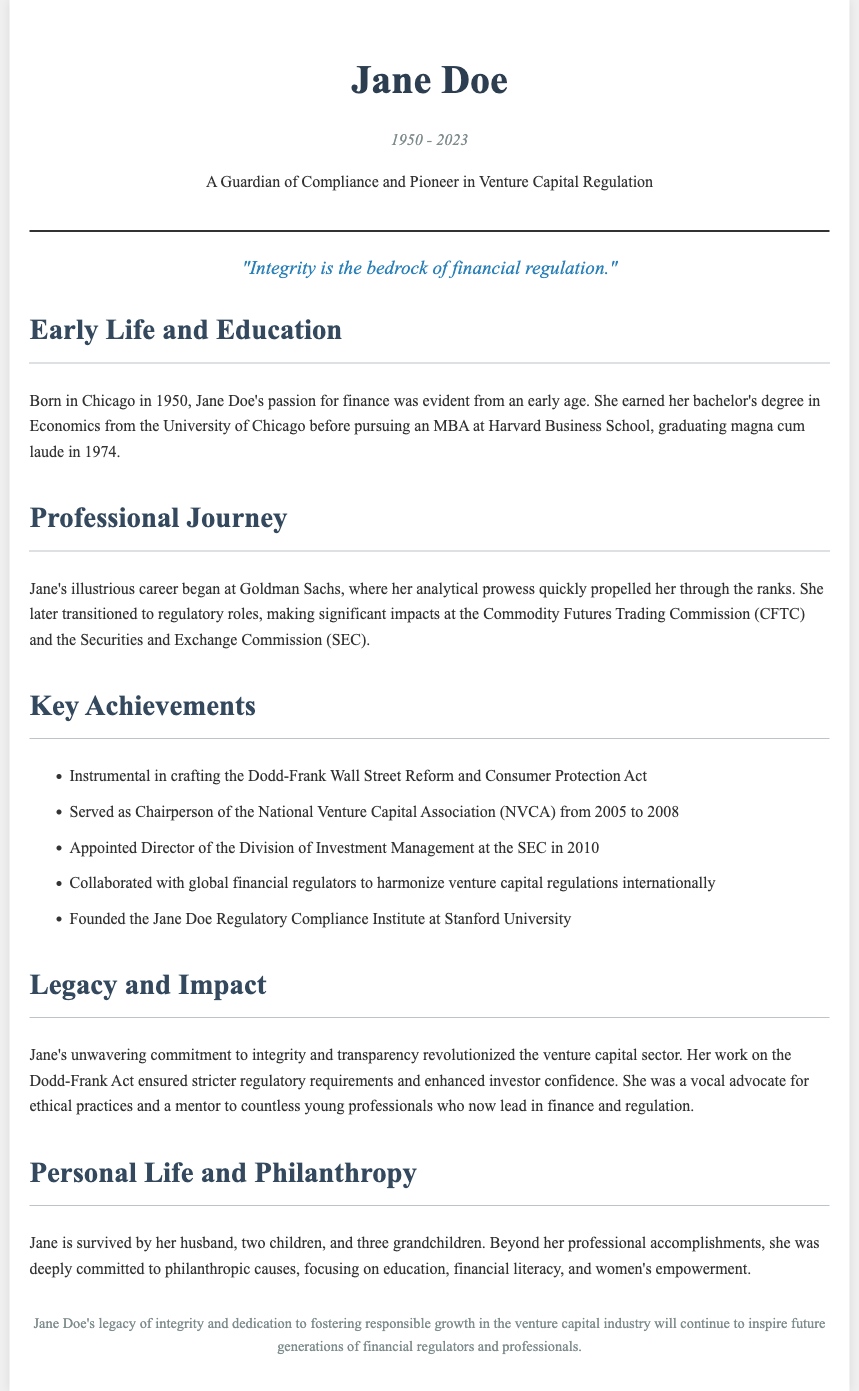What year was Jane Doe born? Jane Doe was born in the year noted in the document, which is 1950.
Answer: 1950 What degree did Jane Doe earn from the University of Chicago? The document states she earned a bachelor's degree in Economics from the University of Chicago.
Answer: Economics Which act did Jane Doe help craft? The act mentioned in the document that she was instrumental in crafting is the Dodd-Frank Wall Street Reform and Consumer Protection Act.
Answer: Dodd-Frank Act How long did Jane Doe serve as Chairperson of the NVCA? The document specifies that she served as Chairperson from 2005 to 2008, which is 3 years.
Answer: 3 years What was Jane Doe's professional starting point? According to the document, Jane Doe's career began at Goldman Sachs.
Answer: Goldman Sachs Which institute did Jane Doe found at Stanford University? The document mentions that she founded the Jane Doe Regulatory Compliance Institute at Stanford University.
Answer: Jane Doe Regulatory Compliance Institute What is one focus of Jane Doe's philanthropic efforts? The document highlights her commitment to various philanthropic causes, including financial literacy.
Answer: Financial literacy How many grandchildren did Jane Doe have? The document notes that Jane is survived by three grandchildren.
Answer: Three grandchildren What quote is attributed to Jane Doe in the document? The document includes the quote "Integrity is the bedrock of financial regulation."
Answer: Integrity is the bedrock of financial regulation 